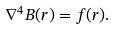Convert formula to latex. <formula><loc_0><loc_0><loc_500><loc_500>\nabla ^ { 4 } B ( r ) = f ( r ) .</formula> 